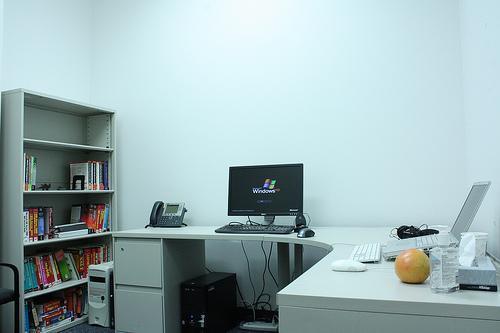How many PC towers are pictured?
Give a very brief answer. 2. How many laptops are shown?
Give a very brief answer. 1. 